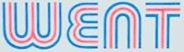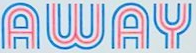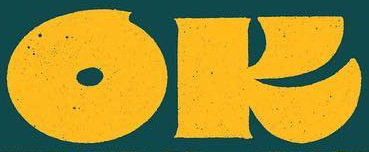Read the text from these images in sequence, separated by a semicolon. WENT; AWAY; OK 